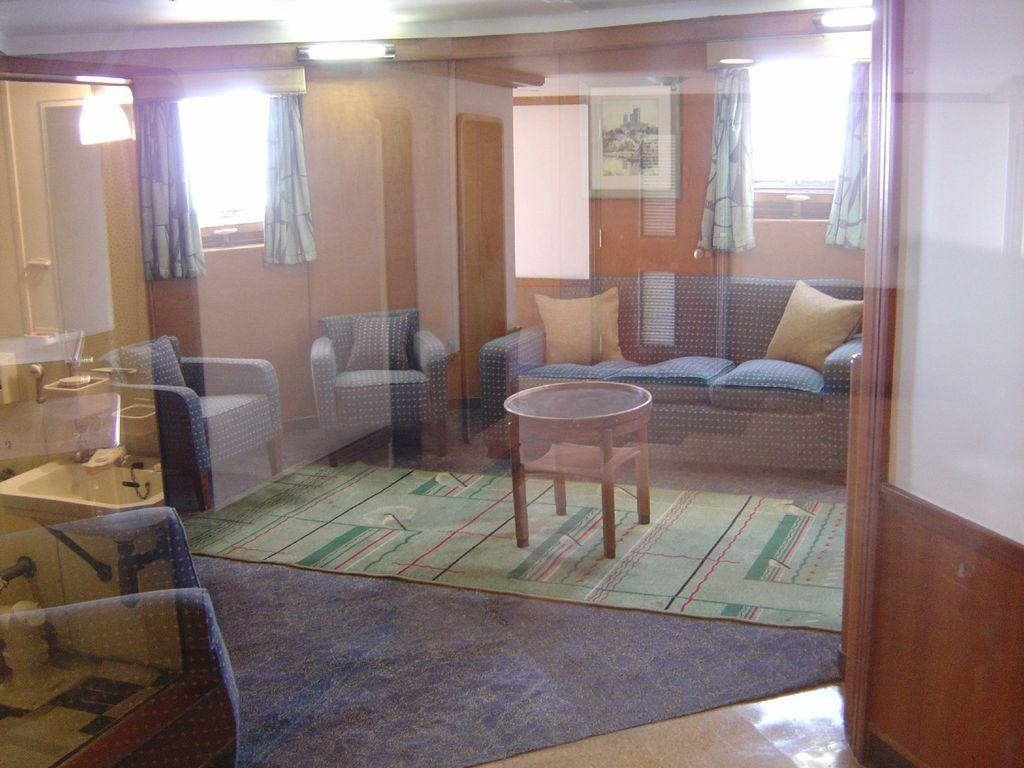What type of structure can be seen in the image? There is a wall in the image. What is located near the wall? There is a window in the image. What is associated with the window? There is a curtain associated with the window. What type of furniture is present in the image? There are sofas in the image. What type of accessory is present on the sofas? There are pillows in the image. Can you describe the ghost that is using the sofas in the image? There is no ghost present in the image, and the sofas are not being used by any visible entities. 